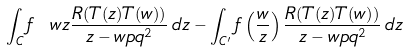Convert formula to latex. <formula><loc_0><loc_0><loc_500><loc_500>\int _ { C } f \ w z \frac { R ( T ( z ) T ( w ) ) } { z - w p q ^ { 2 } } \, d z - \int _ { C ^ { \prime } } f \left ( \frac { w } { z } \right ) \frac { R ( T ( z ) T ( w ) ) } { z - w p q ^ { 2 } } \, d z</formula> 